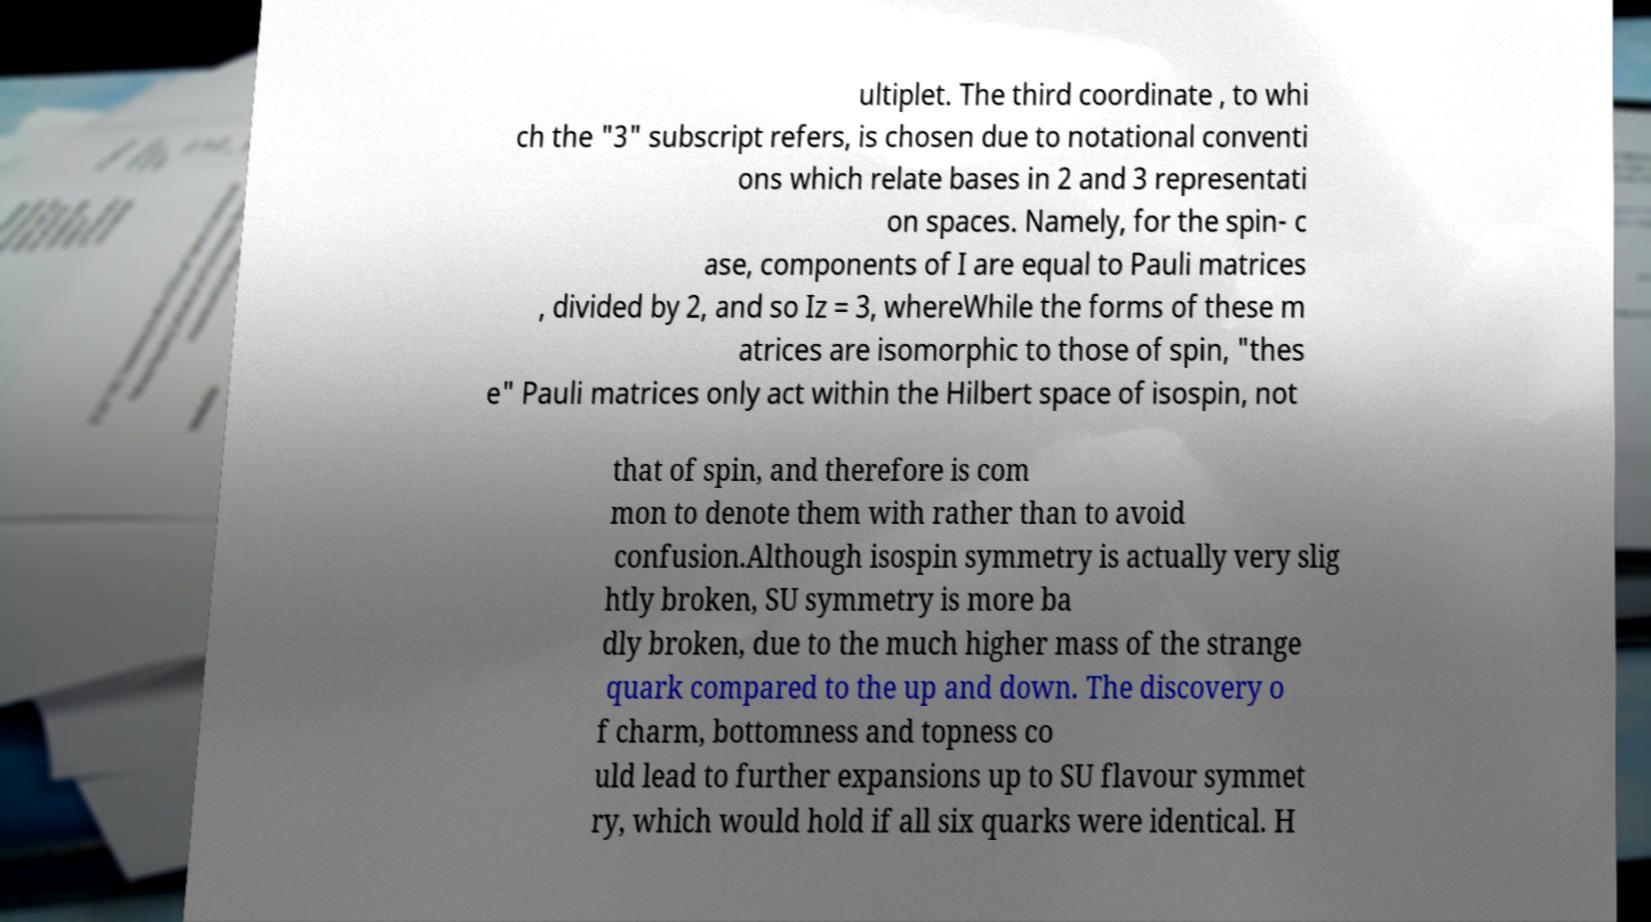Could you assist in decoding the text presented in this image and type it out clearly? ultiplet. The third coordinate , to whi ch the "3" subscript refers, is chosen due to notational conventi ons which relate bases in 2 and 3 representati on spaces. Namely, for the spin- c ase, components of I are equal to Pauli matrices , divided by 2, and so Iz = 3, whereWhile the forms of these m atrices are isomorphic to those of spin, "thes e" Pauli matrices only act within the Hilbert space of isospin, not that of spin, and therefore is com mon to denote them with rather than to avoid confusion.Although isospin symmetry is actually very slig htly broken, SU symmetry is more ba dly broken, due to the much higher mass of the strange quark compared to the up and down. The discovery o f charm, bottomness and topness co uld lead to further expansions up to SU flavour symmet ry, which would hold if all six quarks were identical. H 